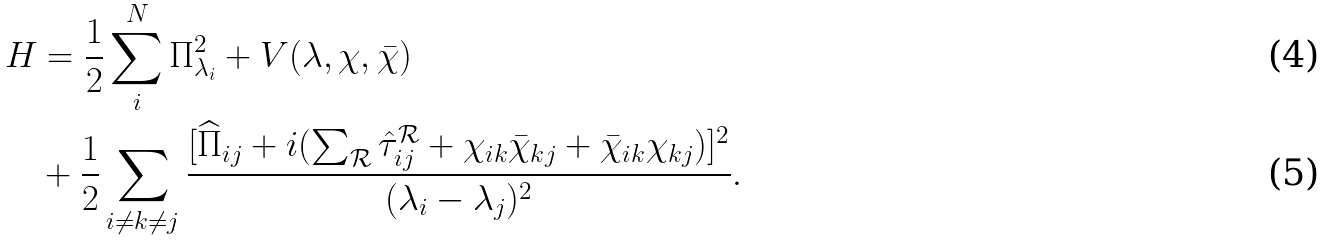Convert formula to latex. <formula><loc_0><loc_0><loc_500><loc_500>H & = \frac { 1 } { 2 } \sum _ { i } ^ { N } \Pi _ { \lambda _ { i } } ^ { 2 } + V ( \lambda , \chi , \bar { \chi } ) \\ & + \frac { 1 } { 2 } \sum _ { i \neq k \neq j } \frac { [ \widehat { \Pi } _ { i j } + i ( \sum _ { \mathcal { R } } \hat { \tau } ^ { \mathcal { R } } _ { i j } + \chi _ { i k } \bar { \chi } _ { k j } + \bar { \chi } _ { i k } \chi _ { k j } ) ] ^ { 2 } } { ( \lambda _ { i } - \lambda _ { j } ) ^ { 2 } } .</formula> 